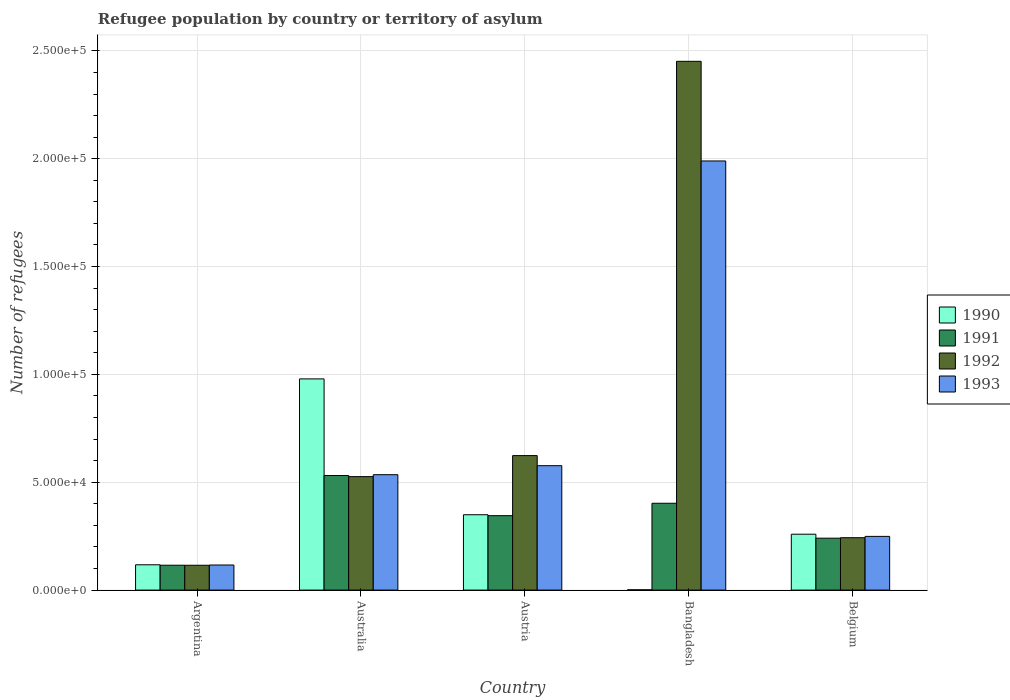How many different coloured bars are there?
Offer a very short reply. 4. Are the number of bars per tick equal to the number of legend labels?
Offer a very short reply. Yes. Are the number of bars on each tick of the X-axis equal?
Offer a terse response. Yes. How many bars are there on the 4th tick from the left?
Your answer should be compact. 4. How many bars are there on the 2nd tick from the right?
Keep it short and to the point. 4. In how many cases, is the number of bars for a given country not equal to the number of legend labels?
Your answer should be very brief. 0. What is the number of refugees in 1993 in Australia?
Offer a terse response. 5.35e+04. Across all countries, what is the maximum number of refugees in 1990?
Ensure brevity in your answer.  9.79e+04. Across all countries, what is the minimum number of refugees in 1990?
Offer a very short reply. 145. In which country was the number of refugees in 1993 maximum?
Ensure brevity in your answer.  Bangladesh. What is the total number of refugees in 1992 in the graph?
Your answer should be compact. 3.96e+05. What is the difference between the number of refugees in 1990 in Argentina and that in Bangladesh?
Offer a terse response. 1.16e+04. What is the difference between the number of refugees in 1991 in Austria and the number of refugees in 1993 in Belgium?
Offer a terse response. 9600. What is the average number of refugees in 1993 per country?
Offer a very short reply. 6.93e+04. What is the difference between the number of refugees of/in 1993 and number of refugees of/in 1991 in Bangladesh?
Your response must be concise. 1.59e+05. What is the ratio of the number of refugees in 1991 in Argentina to that in Belgium?
Provide a succinct answer. 0.48. Is the number of refugees in 1991 in Australia less than that in Bangladesh?
Your response must be concise. No. Is the difference between the number of refugees in 1993 in Bangladesh and Belgium greater than the difference between the number of refugees in 1991 in Bangladesh and Belgium?
Your answer should be compact. Yes. What is the difference between the highest and the second highest number of refugees in 1991?
Your answer should be very brief. -5752. What is the difference between the highest and the lowest number of refugees in 1990?
Your answer should be compact. 9.78e+04. Is it the case that in every country, the sum of the number of refugees in 1990 and number of refugees in 1992 is greater than the sum of number of refugees in 1993 and number of refugees in 1991?
Offer a very short reply. No. How many bars are there?
Provide a short and direct response. 20. Does the graph contain grids?
Ensure brevity in your answer.  Yes. How many legend labels are there?
Offer a terse response. 4. What is the title of the graph?
Provide a short and direct response. Refugee population by country or territory of asylum. What is the label or title of the Y-axis?
Your response must be concise. Number of refugees. What is the Number of refugees in 1990 in Argentina?
Make the answer very short. 1.17e+04. What is the Number of refugees of 1991 in Argentina?
Your answer should be very brief. 1.15e+04. What is the Number of refugees of 1992 in Argentina?
Offer a very short reply. 1.15e+04. What is the Number of refugees of 1993 in Argentina?
Offer a terse response. 1.16e+04. What is the Number of refugees in 1990 in Australia?
Offer a very short reply. 9.79e+04. What is the Number of refugees in 1991 in Australia?
Ensure brevity in your answer.  5.31e+04. What is the Number of refugees in 1992 in Australia?
Keep it short and to the point. 5.26e+04. What is the Number of refugees of 1993 in Australia?
Make the answer very short. 5.35e+04. What is the Number of refugees of 1990 in Austria?
Keep it short and to the point. 3.49e+04. What is the Number of refugees of 1991 in Austria?
Provide a succinct answer. 3.45e+04. What is the Number of refugees of 1992 in Austria?
Your response must be concise. 6.24e+04. What is the Number of refugees in 1993 in Austria?
Keep it short and to the point. 5.77e+04. What is the Number of refugees of 1990 in Bangladesh?
Ensure brevity in your answer.  145. What is the Number of refugees of 1991 in Bangladesh?
Offer a terse response. 4.03e+04. What is the Number of refugees of 1992 in Bangladesh?
Offer a terse response. 2.45e+05. What is the Number of refugees in 1993 in Bangladesh?
Make the answer very short. 1.99e+05. What is the Number of refugees of 1990 in Belgium?
Offer a very short reply. 2.59e+04. What is the Number of refugees of 1991 in Belgium?
Keep it short and to the point. 2.41e+04. What is the Number of refugees in 1992 in Belgium?
Provide a succinct answer. 2.43e+04. What is the Number of refugees in 1993 in Belgium?
Your answer should be compact. 2.49e+04. Across all countries, what is the maximum Number of refugees in 1990?
Provide a short and direct response. 9.79e+04. Across all countries, what is the maximum Number of refugees of 1991?
Your answer should be compact. 5.31e+04. Across all countries, what is the maximum Number of refugees of 1992?
Give a very brief answer. 2.45e+05. Across all countries, what is the maximum Number of refugees of 1993?
Offer a very short reply. 1.99e+05. Across all countries, what is the minimum Number of refugees of 1990?
Ensure brevity in your answer.  145. Across all countries, what is the minimum Number of refugees of 1991?
Ensure brevity in your answer.  1.15e+04. Across all countries, what is the minimum Number of refugees of 1992?
Keep it short and to the point. 1.15e+04. Across all countries, what is the minimum Number of refugees of 1993?
Make the answer very short. 1.16e+04. What is the total Number of refugees in 1990 in the graph?
Make the answer very short. 1.71e+05. What is the total Number of refugees of 1991 in the graph?
Offer a very short reply. 1.63e+05. What is the total Number of refugees of 1992 in the graph?
Ensure brevity in your answer.  3.96e+05. What is the total Number of refugees of 1993 in the graph?
Provide a succinct answer. 3.47e+05. What is the difference between the Number of refugees of 1990 in Argentina and that in Australia?
Offer a terse response. -8.62e+04. What is the difference between the Number of refugees in 1991 in Argentina and that in Australia?
Make the answer very short. -4.16e+04. What is the difference between the Number of refugees in 1992 in Argentina and that in Australia?
Provide a short and direct response. -4.11e+04. What is the difference between the Number of refugees in 1993 in Argentina and that in Australia?
Ensure brevity in your answer.  -4.19e+04. What is the difference between the Number of refugees of 1990 in Argentina and that in Austria?
Offer a terse response. -2.32e+04. What is the difference between the Number of refugees in 1991 in Argentina and that in Austria?
Provide a succinct answer. -2.30e+04. What is the difference between the Number of refugees of 1992 in Argentina and that in Austria?
Your answer should be very brief. -5.08e+04. What is the difference between the Number of refugees in 1993 in Argentina and that in Austria?
Your answer should be very brief. -4.61e+04. What is the difference between the Number of refugees in 1990 in Argentina and that in Bangladesh?
Give a very brief answer. 1.16e+04. What is the difference between the Number of refugees in 1991 in Argentina and that in Bangladesh?
Provide a succinct answer. -2.87e+04. What is the difference between the Number of refugees in 1992 in Argentina and that in Bangladesh?
Keep it short and to the point. -2.34e+05. What is the difference between the Number of refugees of 1993 in Argentina and that in Bangladesh?
Offer a very short reply. -1.87e+05. What is the difference between the Number of refugees in 1990 in Argentina and that in Belgium?
Provide a succinct answer. -1.42e+04. What is the difference between the Number of refugees of 1991 in Argentina and that in Belgium?
Ensure brevity in your answer.  -1.25e+04. What is the difference between the Number of refugees in 1992 in Argentina and that in Belgium?
Ensure brevity in your answer.  -1.28e+04. What is the difference between the Number of refugees of 1993 in Argentina and that in Belgium?
Provide a succinct answer. -1.33e+04. What is the difference between the Number of refugees in 1990 in Australia and that in Austria?
Your answer should be compact. 6.30e+04. What is the difference between the Number of refugees of 1991 in Australia and that in Austria?
Offer a very short reply. 1.86e+04. What is the difference between the Number of refugees in 1992 in Australia and that in Austria?
Provide a short and direct response. -9751. What is the difference between the Number of refugees in 1993 in Australia and that in Austria?
Keep it short and to the point. -4182. What is the difference between the Number of refugees in 1990 in Australia and that in Bangladesh?
Provide a short and direct response. 9.78e+04. What is the difference between the Number of refugees of 1991 in Australia and that in Bangladesh?
Ensure brevity in your answer.  1.29e+04. What is the difference between the Number of refugees of 1992 in Australia and that in Bangladesh?
Your response must be concise. -1.93e+05. What is the difference between the Number of refugees of 1993 in Australia and that in Bangladesh?
Your response must be concise. -1.45e+05. What is the difference between the Number of refugees in 1990 in Australia and that in Belgium?
Your answer should be very brief. 7.20e+04. What is the difference between the Number of refugees of 1991 in Australia and that in Belgium?
Offer a terse response. 2.90e+04. What is the difference between the Number of refugees in 1992 in Australia and that in Belgium?
Give a very brief answer. 2.83e+04. What is the difference between the Number of refugees of 1993 in Australia and that in Belgium?
Provide a short and direct response. 2.86e+04. What is the difference between the Number of refugees in 1990 in Austria and that in Bangladesh?
Give a very brief answer. 3.48e+04. What is the difference between the Number of refugees in 1991 in Austria and that in Bangladesh?
Provide a short and direct response. -5752. What is the difference between the Number of refugees in 1992 in Austria and that in Bangladesh?
Keep it short and to the point. -1.83e+05. What is the difference between the Number of refugees in 1993 in Austria and that in Bangladesh?
Give a very brief answer. -1.41e+05. What is the difference between the Number of refugees in 1990 in Austria and that in Belgium?
Your answer should be compact. 9027. What is the difference between the Number of refugees in 1991 in Austria and that in Belgium?
Keep it short and to the point. 1.04e+04. What is the difference between the Number of refugees in 1992 in Austria and that in Belgium?
Your answer should be very brief. 3.81e+04. What is the difference between the Number of refugees of 1993 in Austria and that in Belgium?
Keep it short and to the point. 3.28e+04. What is the difference between the Number of refugees of 1990 in Bangladesh and that in Belgium?
Offer a terse response. -2.58e+04. What is the difference between the Number of refugees of 1991 in Bangladesh and that in Belgium?
Offer a very short reply. 1.62e+04. What is the difference between the Number of refugees in 1992 in Bangladesh and that in Belgium?
Make the answer very short. 2.21e+05. What is the difference between the Number of refugees of 1993 in Bangladesh and that in Belgium?
Your answer should be compact. 1.74e+05. What is the difference between the Number of refugees in 1990 in Argentina and the Number of refugees in 1991 in Australia?
Provide a succinct answer. -4.14e+04. What is the difference between the Number of refugees in 1990 in Argentina and the Number of refugees in 1992 in Australia?
Your response must be concise. -4.09e+04. What is the difference between the Number of refugees of 1990 in Argentina and the Number of refugees of 1993 in Australia?
Give a very brief answer. -4.18e+04. What is the difference between the Number of refugees in 1991 in Argentina and the Number of refugees in 1992 in Australia?
Keep it short and to the point. -4.11e+04. What is the difference between the Number of refugees in 1991 in Argentina and the Number of refugees in 1993 in Australia?
Your answer should be compact. -4.20e+04. What is the difference between the Number of refugees in 1992 in Argentina and the Number of refugees in 1993 in Australia?
Your answer should be compact. -4.20e+04. What is the difference between the Number of refugees of 1990 in Argentina and the Number of refugees of 1991 in Austria?
Give a very brief answer. -2.28e+04. What is the difference between the Number of refugees of 1990 in Argentina and the Number of refugees of 1992 in Austria?
Your response must be concise. -5.06e+04. What is the difference between the Number of refugees in 1990 in Argentina and the Number of refugees in 1993 in Austria?
Your response must be concise. -4.60e+04. What is the difference between the Number of refugees of 1991 in Argentina and the Number of refugees of 1992 in Austria?
Your response must be concise. -5.08e+04. What is the difference between the Number of refugees of 1991 in Argentina and the Number of refugees of 1993 in Austria?
Keep it short and to the point. -4.62e+04. What is the difference between the Number of refugees of 1992 in Argentina and the Number of refugees of 1993 in Austria?
Offer a very short reply. -4.62e+04. What is the difference between the Number of refugees of 1990 in Argentina and the Number of refugees of 1991 in Bangladesh?
Your answer should be very brief. -2.85e+04. What is the difference between the Number of refugees of 1990 in Argentina and the Number of refugees of 1992 in Bangladesh?
Provide a succinct answer. -2.33e+05. What is the difference between the Number of refugees in 1990 in Argentina and the Number of refugees in 1993 in Bangladesh?
Your answer should be compact. -1.87e+05. What is the difference between the Number of refugees in 1991 in Argentina and the Number of refugees in 1992 in Bangladesh?
Make the answer very short. -2.34e+05. What is the difference between the Number of refugees in 1991 in Argentina and the Number of refugees in 1993 in Bangladesh?
Give a very brief answer. -1.87e+05. What is the difference between the Number of refugees in 1992 in Argentina and the Number of refugees in 1993 in Bangladesh?
Your response must be concise. -1.87e+05. What is the difference between the Number of refugees of 1990 in Argentina and the Number of refugees of 1991 in Belgium?
Give a very brief answer. -1.23e+04. What is the difference between the Number of refugees in 1990 in Argentina and the Number of refugees in 1992 in Belgium?
Ensure brevity in your answer.  -1.26e+04. What is the difference between the Number of refugees in 1990 in Argentina and the Number of refugees in 1993 in Belgium?
Your response must be concise. -1.32e+04. What is the difference between the Number of refugees of 1991 in Argentina and the Number of refugees of 1992 in Belgium?
Provide a short and direct response. -1.28e+04. What is the difference between the Number of refugees of 1991 in Argentina and the Number of refugees of 1993 in Belgium?
Your response must be concise. -1.34e+04. What is the difference between the Number of refugees in 1992 in Argentina and the Number of refugees in 1993 in Belgium?
Make the answer very short. -1.34e+04. What is the difference between the Number of refugees in 1990 in Australia and the Number of refugees in 1991 in Austria?
Your response must be concise. 6.34e+04. What is the difference between the Number of refugees of 1990 in Australia and the Number of refugees of 1992 in Austria?
Give a very brief answer. 3.56e+04. What is the difference between the Number of refugees of 1990 in Australia and the Number of refugees of 1993 in Austria?
Your response must be concise. 4.02e+04. What is the difference between the Number of refugees of 1991 in Australia and the Number of refugees of 1992 in Austria?
Offer a terse response. -9238. What is the difference between the Number of refugees in 1991 in Australia and the Number of refugees in 1993 in Austria?
Ensure brevity in your answer.  -4570. What is the difference between the Number of refugees in 1992 in Australia and the Number of refugees in 1993 in Austria?
Keep it short and to the point. -5083. What is the difference between the Number of refugees of 1990 in Australia and the Number of refugees of 1991 in Bangladesh?
Your response must be concise. 5.77e+04. What is the difference between the Number of refugees in 1990 in Australia and the Number of refugees in 1992 in Bangladesh?
Give a very brief answer. -1.47e+05. What is the difference between the Number of refugees of 1990 in Australia and the Number of refugees of 1993 in Bangladesh?
Keep it short and to the point. -1.01e+05. What is the difference between the Number of refugees of 1991 in Australia and the Number of refugees of 1992 in Bangladesh?
Your answer should be very brief. -1.92e+05. What is the difference between the Number of refugees in 1991 in Australia and the Number of refugees in 1993 in Bangladesh?
Your answer should be compact. -1.46e+05. What is the difference between the Number of refugees in 1992 in Australia and the Number of refugees in 1993 in Bangladesh?
Keep it short and to the point. -1.46e+05. What is the difference between the Number of refugees of 1990 in Australia and the Number of refugees of 1991 in Belgium?
Provide a short and direct response. 7.38e+04. What is the difference between the Number of refugees of 1990 in Australia and the Number of refugees of 1992 in Belgium?
Offer a terse response. 7.36e+04. What is the difference between the Number of refugees in 1990 in Australia and the Number of refugees in 1993 in Belgium?
Make the answer very short. 7.30e+04. What is the difference between the Number of refugees in 1991 in Australia and the Number of refugees in 1992 in Belgium?
Ensure brevity in your answer.  2.88e+04. What is the difference between the Number of refugees of 1991 in Australia and the Number of refugees of 1993 in Belgium?
Your response must be concise. 2.82e+04. What is the difference between the Number of refugees of 1992 in Australia and the Number of refugees of 1993 in Belgium?
Ensure brevity in your answer.  2.77e+04. What is the difference between the Number of refugees of 1990 in Austria and the Number of refugees of 1991 in Bangladesh?
Offer a very short reply. -5322. What is the difference between the Number of refugees of 1990 in Austria and the Number of refugees of 1992 in Bangladesh?
Your answer should be very brief. -2.10e+05. What is the difference between the Number of refugees in 1990 in Austria and the Number of refugees in 1993 in Bangladesh?
Ensure brevity in your answer.  -1.64e+05. What is the difference between the Number of refugees of 1991 in Austria and the Number of refugees of 1992 in Bangladesh?
Ensure brevity in your answer.  -2.11e+05. What is the difference between the Number of refugees in 1991 in Austria and the Number of refugees in 1993 in Bangladesh?
Ensure brevity in your answer.  -1.64e+05. What is the difference between the Number of refugees of 1992 in Austria and the Number of refugees of 1993 in Bangladesh?
Provide a short and direct response. -1.37e+05. What is the difference between the Number of refugees in 1990 in Austria and the Number of refugees in 1991 in Belgium?
Give a very brief answer. 1.09e+04. What is the difference between the Number of refugees of 1990 in Austria and the Number of refugees of 1992 in Belgium?
Make the answer very short. 1.06e+04. What is the difference between the Number of refugees of 1990 in Austria and the Number of refugees of 1993 in Belgium?
Make the answer very short. 1.00e+04. What is the difference between the Number of refugees in 1991 in Austria and the Number of refugees in 1992 in Belgium?
Keep it short and to the point. 1.02e+04. What is the difference between the Number of refugees in 1991 in Austria and the Number of refugees in 1993 in Belgium?
Provide a succinct answer. 9600. What is the difference between the Number of refugees of 1992 in Austria and the Number of refugees of 1993 in Belgium?
Ensure brevity in your answer.  3.74e+04. What is the difference between the Number of refugees of 1990 in Bangladesh and the Number of refugees of 1991 in Belgium?
Offer a very short reply. -2.39e+04. What is the difference between the Number of refugees of 1990 in Bangladesh and the Number of refugees of 1992 in Belgium?
Give a very brief answer. -2.41e+04. What is the difference between the Number of refugees in 1990 in Bangladesh and the Number of refugees in 1993 in Belgium?
Offer a very short reply. -2.48e+04. What is the difference between the Number of refugees of 1991 in Bangladesh and the Number of refugees of 1992 in Belgium?
Provide a succinct answer. 1.60e+04. What is the difference between the Number of refugees in 1991 in Bangladesh and the Number of refugees in 1993 in Belgium?
Make the answer very short. 1.54e+04. What is the difference between the Number of refugees in 1992 in Bangladesh and the Number of refugees in 1993 in Belgium?
Your answer should be very brief. 2.20e+05. What is the average Number of refugees of 1990 per country?
Offer a very short reply. 3.41e+04. What is the average Number of refugees in 1991 per country?
Give a very brief answer. 3.27e+04. What is the average Number of refugees of 1992 per country?
Your response must be concise. 7.92e+04. What is the average Number of refugees of 1993 per country?
Your answer should be compact. 6.93e+04. What is the difference between the Number of refugees of 1990 and Number of refugees of 1991 in Argentina?
Make the answer very short. 206. What is the difference between the Number of refugees in 1990 and Number of refugees in 1992 in Argentina?
Your response must be concise. 220. What is the difference between the Number of refugees of 1991 and Number of refugees of 1992 in Argentina?
Provide a succinct answer. 14. What is the difference between the Number of refugees in 1991 and Number of refugees in 1993 in Argentina?
Give a very brief answer. -107. What is the difference between the Number of refugees of 1992 and Number of refugees of 1993 in Argentina?
Give a very brief answer. -121. What is the difference between the Number of refugees in 1990 and Number of refugees in 1991 in Australia?
Your response must be concise. 4.48e+04. What is the difference between the Number of refugees of 1990 and Number of refugees of 1992 in Australia?
Give a very brief answer. 4.53e+04. What is the difference between the Number of refugees of 1990 and Number of refugees of 1993 in Australia?
Your answer should be compact. 4.44e+04. What is the difference between the Number of refugees in 1991 and Number of refugees in 1992 in Australia?
Offer a terse response. 513. What is the difference between the Number of refugees of 1991 and Number of refugees of 1993 in Australia?
Give a very brief answer. -388. What is the difference between the Number of refugees in 1992 and Number of refugees in 1993 in Australia?
Your answer should be compact. -901. What is the difference between the Number of refugees in 1990 and Number of refugees in 1991 in Austria?
Your answer should be compact. 430. What is the difference between the Number of refugees in 1990 and Number of refugees in 1992 in Austria?
Provide a short and direct response. -2.74e+04. What is the difference between the Number of refugees of 1990 and Number of refugees of 1993 in Austria?
Your answer should be very brief. -2.27e+04. What is the difference between the Number of refugees of 1991 and Number of refugees of 1992 in Austria?
Your response must be concise. -2.78e+04. What is the difference between the Number of refugees in 1991 and Number of refugees in 1993 in Austria?
Ensure brevity in your answer.  -2.32e+04. What is the difference between the Number of refugees of 1992 and Number of refugees of 1993 in Austria?
Make the answer very short. 4668. What is the difference between the Number of refugees in 1990 and Number of refugees in 1991 in Bangladesh?
Offer a very short reply. -4.01e+04. What is the difference between the Number of refugees of 1990 and Number of refugees of 1992 in Bangladesh?
Offer a terse response. -2.45e+05. What is the difference between the Number of refugees of 1990 and Number of refugees of 1993 in Bangladesh?
Provide a succinct answer. -1.99e+05. What is the difference between the Number of refugees in 1991 and Number of refugees in 1992 in Bangladesh?
Provide a short and direct response. -2.05e+05. What is the difference between the Number of refugees in 1991 and Number of refugees in 1993 in Bangladesh?
Your answer should be compact. -1.59e+05. What is the difference between the Number of refugees of 1992 and Number of refugees of 1993 in Bangladesh?
Your answer should be very brief. 4.62e+04. What is the difference between the Number of refugees in 1990 and Number of refugees in 1991 in Belgium?
Keep it short and to the point. 1840. What is the difference between the Number of refugees in 1990 and Number of refugees in 1992 in Belgium?
Your answer should be very brief. 1619. What is the difference between the Number of refugees in 1990 and Number of refugees in 1993 in Belgium?
Give a very brief answer. 1003. What is the difference between the Number of refugees of 1991 and Number of refugees of 1992 in Belgium?
Ensure brevity in your answer.  -221. What is the difference between the Number of refugees in 1991 and Number of refugees in 1993 in Belgium?
Keep it short and to the point. -837. What is the difference between the Number of refugees of 1992 and Number of refugees of 1993 in Belgium?
Offer a very short reply. -616. What is the ratio of the Number of refugees in 1990 in Argentina to that in Australia?
Give a very brief answer. 0.12. What is the ratio of the Number of refugees of 1991 in Argentina to that in Australia?
Provide a succinct answer. 0.22. What is the ratio of the Number of refugees of 1992 in Argentina to that in Australia?
Make the answer very short. 0.22. What is the ratio of the Number of refugees in 1993 in Argentina to that in Australia?
Offer a terse response. 0.22. What is the ratio of the Number of refugees in 1990 in Argentina to that in Austria?
Give a very brief answer. 0.34. What is the ratio of the Number of refugees of 1991 in Argentina to that in Austria?
Your answer should be very brief. 0.33. What is the ratio of the Number of refugees of 1992 in Argentina to that in Austria?
Provide a succinct answer. 0.18. What is the ratio of the Number of refugees of 1993 in Argentina to that in Austria?
Offer a terse response. 0.2. What is the ratio of the Number of refugees of 1990 in Argentina to that in Bangladesh?
Offer a very short reply. 80.93. What is the ratio of the Number of refugees in 1991 in Argentina to that in Bangladesh?
Make the answer very short. 0.29. What is the ratio of the Number of refugees in 1992 in Argentina to that in Bangladesh?
Provide a succinct answer. 0.05. What is the ratio of the Number of refugees of 1993 in Argentina to that in Bangladesh?
Make the answer very short. 0.06. What is the ratio of the Number of refugees in 1990 in Argentina to that in Belgium?
Your answer should be compact. 0.45. What is the ratio of the Number of refugees in 1991 in Argentina to that in Belgium?
Provide a succinct answer. 0.48. What is the ratio of the Number of refugees of 1992 in Argentina to that in Belgium?
Provide a succinct answer. 0.47. What is the ratio of the Number of refugees of 1993 in Argentina to that in Belgium?
Provide a succinct answer. 0.47. What is the ratio of the Number of refugees in 1990 in Australia to that in Austria?
Ensure brevity in your answer.  2.8. What is the ratio of the Number of refugees in 1991 in Australia to that in Austria?
Provide a short and direct response. 1.54. What is the ratio of the Number of refugees of 1992 in Australia to that in Austria?
Ensure brevity in your answer.  0.84. What is the ratio of the Number of refugees of 1993 in Australia to that in Austria?
Provide a short and direct response. 0.93. What is the ratio of the Number of refugees of 1990 in Australia to that in Bangladesh?
Keep it short and to the point. 675.28. What is the ratio of the Number of refugees of 1991 in Australia to that in Bangladesh?
Provide a succinct answer. 1.32. What is the ratio of the Number of refugees of 1992 in Australia to that in Bangladesh?
Provide a short and direct response. 0.21. What is the ratio of the Number of refugees of 1993 in Australia to that in Bangladesh?
Give a very brief answer. 0.27. What is the ratio of the Number of refugees in 1990 in Australia to that in Belgium?
Keep it short and to the point. 3.78. What is the ratio of the Number of refugees in 1991 in Australia to that in Belgium?
Your response must be concise. 2.21. What is the ratio of the Number of refugees in 1992 in Australia to that in Belgium?
Your answer should be compact. 2.17. What is the ratio of the Number of refugees in 1993 in Australia to that in Belgium?
Give a very brief answer. 2.15. What is the ratio of the Number of refugees in 1990 in Austria to that in Bangladesh?
Your answer should be compact. 240.95. What is the ratio of the Number of refugees in 1992 in Austria to that in Bangladesh?
Provide a succinct answer. 0.25. What is the ratio of the Number of refugees of 1993 in Austria to that in Bangladesh?
Give a very brief answer. 0.29. What is the ratio of the Number of refugees of 1990 in Austria to that in Belgium?
Your response must be concise. 1.35. What is the ratio of the Number of refugees in 1991 in Austria to that in Belgium?
Offer a very short reply. 1.43. What is the ratio of the Number of refugees in 1992 in Austria to that in Belgium?
Your answer should be very brief. 2.57. What is the ratio of the Number of refugees of 1993 in Austria to that in Belgium?
Provide a succinct answer. 2.32. What is the ratio of the Number of refugees in 1990 in Bangladesh to that in Belgium?
Provide a short and direct response. 0.01. What is the ratio of the Number of refugees in 1991 in Bangladesh to that in Belgium?
Give a very brief answer. 1.67. What is the ratio of the Number of refugees of 1992 in Bangladesh to that in Belgium?
Your answer should be compact. 10.09. What is the ratio of the Number of refugees of 1993 in Bangladesh to that in Belgium?
Provide a short and direct response. 7.99. What is the difference between the highest and the second highest Number of refugees in 1990?
Give a very brief answer. 6.30e+04. What is the difference between the highest and the second highest Number of refugees in 1991?
Provide a succinct answer. 1.29e+04. What is the difference between the highest and the second highest Number of refugees in 1992?
Ensure brevity in your answer.  1.83e+05. What is the difference between the highest and the second highest Number of refugees in 1993?
Provide a succinct answer. 1.41e+05. What is the difference between the highest and the lowest Number of refugees of 1990?
Your response must be concise. 9.78e+04. What is the difference between the highest and the lowest Number of refugees of 1991?
Your answer should be very brief. 4.16e+04. What is the difference between the highest and the lowest Number of refugees in 1992?
Your answer should be very brief. 2.34e+05. What is the difference between the highest and the lowest Number of refugees of 1993?
Your answer should be very brief. 1.87e+05. 